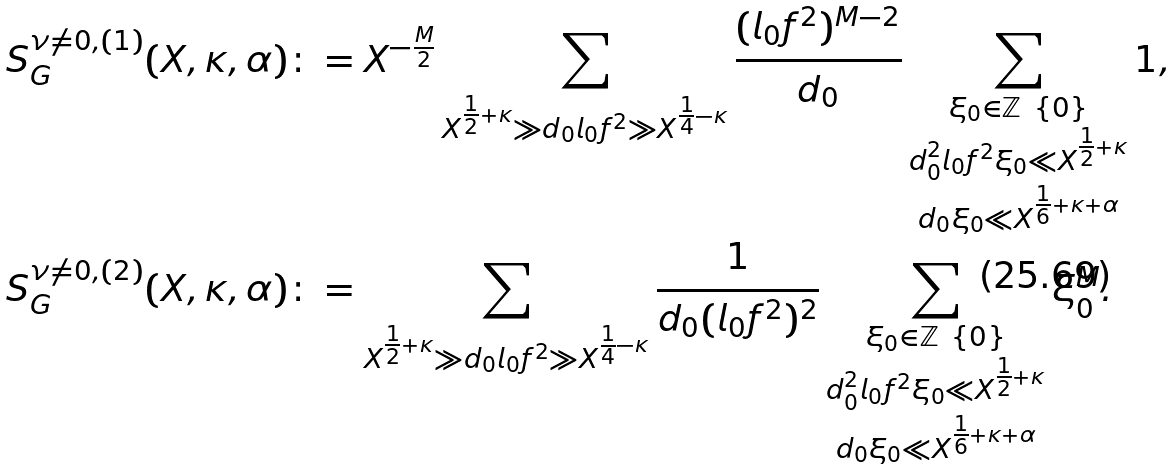Convert formula to latex. <formula><loc_0><loc_0><loc_500><loc_500>S _ { G } ^ { \nu \neq 0 , ( 1 ) } ( X , \kappa , \alpha ) \colon & = X ^ { - \frac { M } 2 } \sum _ { X ^ { \frac { 1 } { 2 } + \kappa } \gg d _ { 0 } l _ { 0 } f ^ { 2 } \gg X ^ { \frac { 1 } { 4 } - \kappa } } \frac { ( l _ { 0 } f ^ { 2 } ) ^ { M - 2 } } { d _ { 0 } } \sum _ { \substack { \xi _ { 0 } \in \mathbb { Z } \ \{ 0 \} \\ d _ { 0 } ^ { 2 } l _ { 0 } f ^ { 2 } \xi _ { 0 } \ll X ^ { \frac { 1 } { 2 } + \kappa } \\ d _ { 0 } \xi _ { 0 } \ll X ^ { \frac { 1 } { 6 } + \kappa + \alpha } } } 1 , \\ S _ { G } ^ { \nu \neq 0 , ( 2 ) } ( X , \kappa , \alpha ) \colon & = \sum _ { X ^ { \frac { 1 } { 2 } + \kappa } \gg d _ { 0 } l _ { 0 } f ^ { 2 } \gg X ^ { \frac { 1 } { 4 } - \kappa } } \frac { 1 } { d _ { 0 } ( l _ { 0 } f ^ { 2 } ) ^ { 2 } } \sum _ { \substack { \xi _ { 0 } \in \mathbb { Z } \ \{ 0 \} \\ d _ { 0 } ^ { 2 } l _ { 0 } f ^ { 2 } \xi _ { 0 } \ll X ^ { \frac { 1 } { 2 } + \kappa } \\ d _ { 0 } \xi _ { 0 } \ll X ^ { \frac { 1 } { 6 } + \kappa + \alpha } } } \xi _ { 0 } ^ { M } .</formula> 